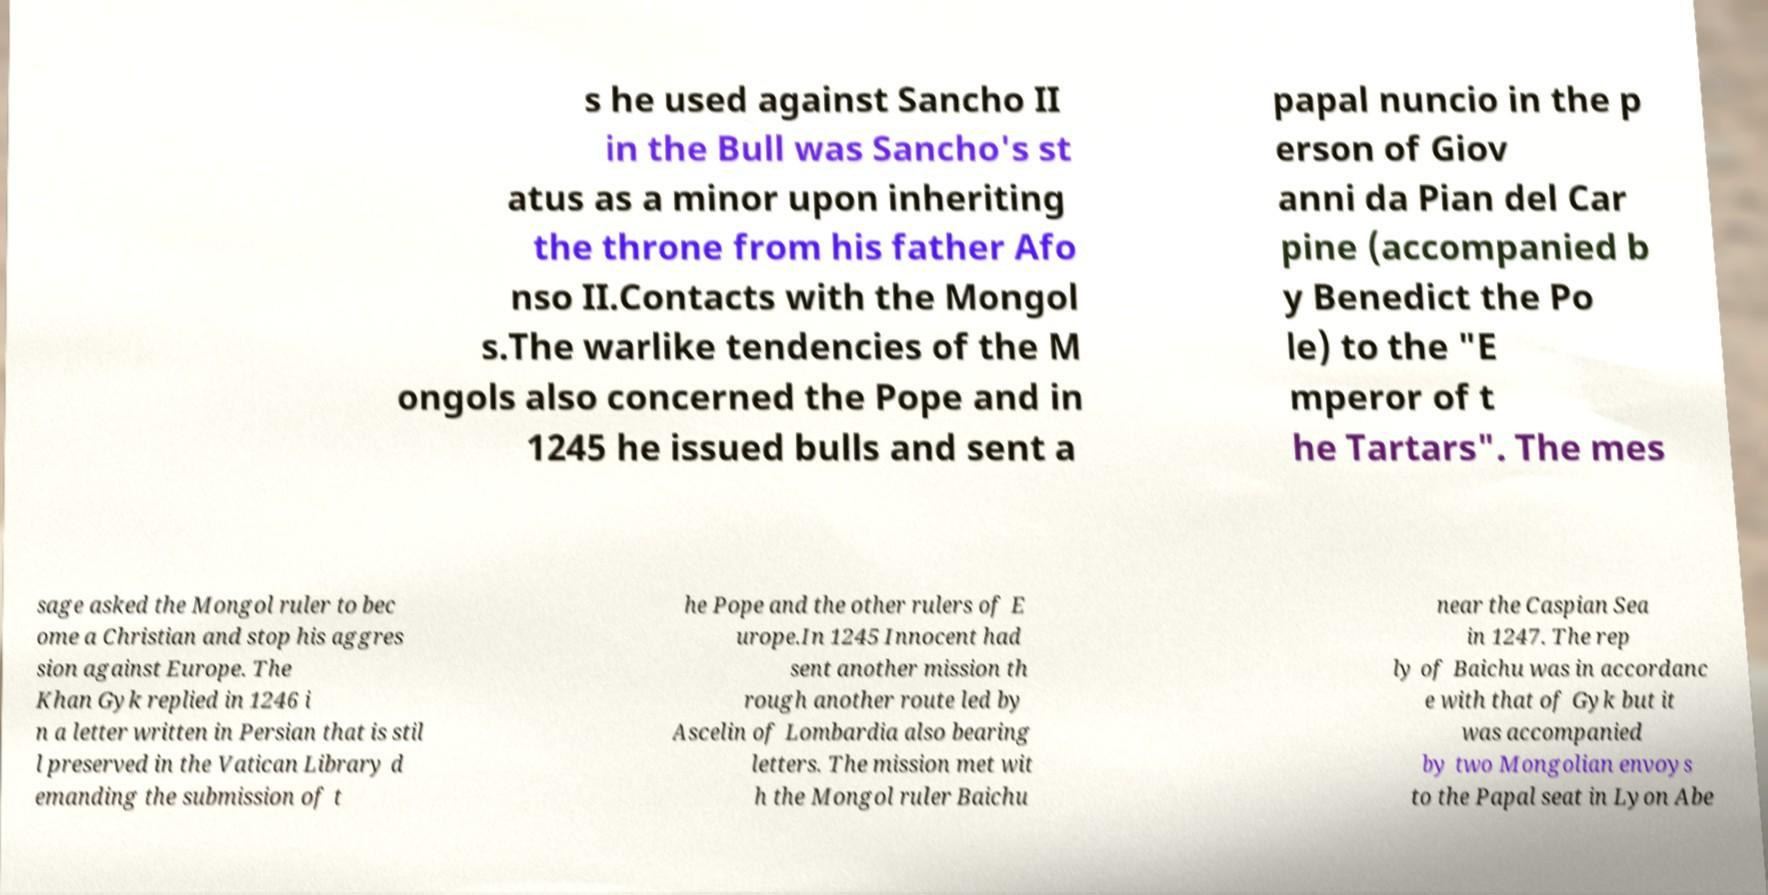Please read and relay the text visible in this image. What does it say? s he used against Sancho II in the Bull was Sancho's st atus as a minor upon inheriting the throne from his father Afo nso II.Contacts with the Mongol s.The warlike tendencies of the M ongols also concerned the Pope and in 1245 he issued bulls and sent a papal nuncio in the p erson of Giov anni da Pian del Car pine (accompanied b y Benedict the Po le) to the "E mperor of t he Tartars". The mes sage asked the Mongol ruler to bec ome a Christian and stop his aggres sion against Europe. The Khan Gyk replied in 1246 i n a letter written in Persian that is stil l preserved in the Vatican Library d emanding the submission of t he Pope and the other rulers of E urope.In 1245 Innocent had sent another mission th rough another route led by Ascelin of Lombardia also bearing letters. The mission met wit h the Mongol ruler Baichu near the Caspian Sea in 1247. The rep ly of Baichu was in accordanc e with that of Gyk but it was accompanied by two Mongolian envoys to the Papal seat in Lyon Abe 